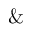Convert formula to latex. <formula><loc_0><loc_0><loc_500><loc_500>\&</formula> 